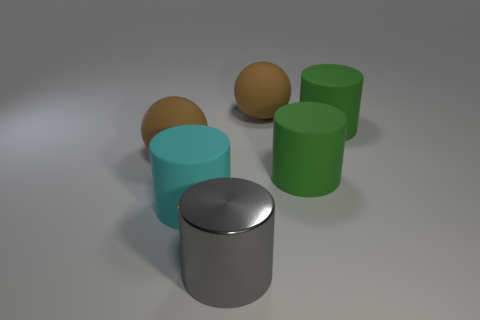What number of cyan things are either matte objects or rubber spheres?
Offer a very short reply. 1. There is another large cyan object that is the same shape as the big metallic object; what is it made of?
Your answer should be very brief. Rubber. What number of other things are the same size as the cyan object?
Your answer should be very brief. 5. What is the shape of the brown thing behind the brown sphere that is left of the brown rubber sphere that is to the right of the gray thing?
Provide a succinct answer. Sphere. There is a large object that is to the left of the metal thing and behind the big cyan matte thing; what shape is it?
Ensure brevity in your answer.  Sphere. What number of things are either big gray shiny cylinders or brown rubber things left of the cyan thing?
Your answer should be very brief. 2. How many other objects are the same shape as the gray thing?
Give a very brief answer. 3. How big is the object that is behind the cyan rubber cylinder and left of the gray object?
Offer a terse response. Large. What number of matte things are large cylinders or large cyan cylinders?
Give a very brief answer. 3. Is the shape of the brown matte object to the right of the big gray object the same as the matte thing that is on the left side of the big cyan object?
Keep it short and to the point. Yes. 